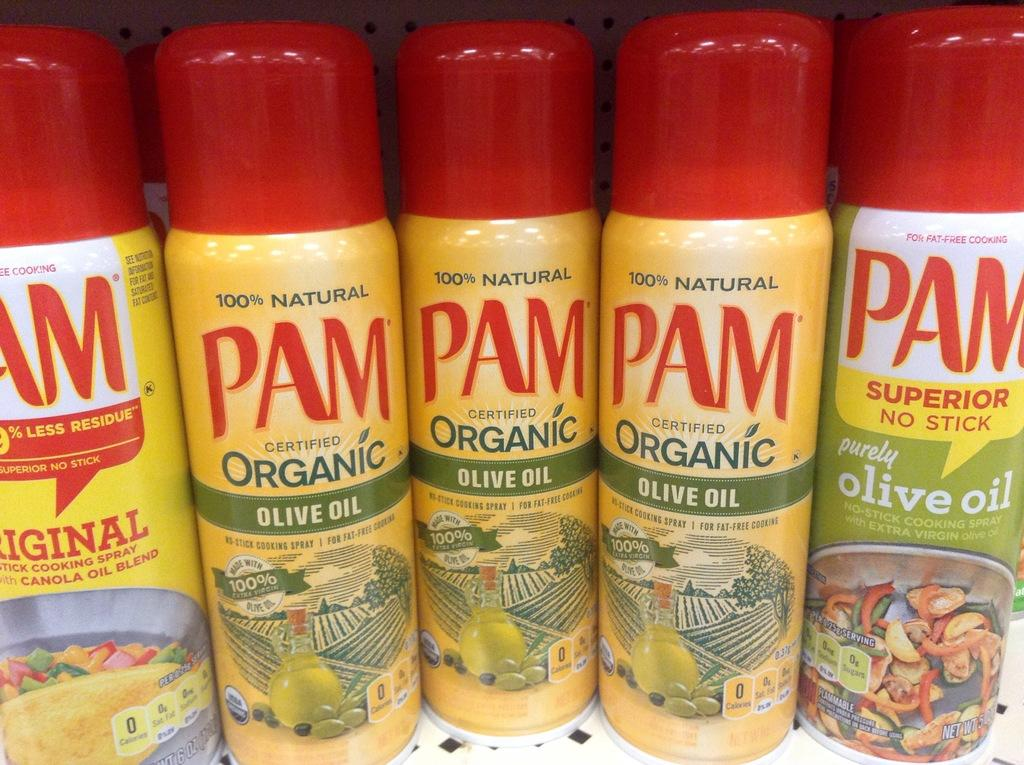What objects are present in the image? There are bottles in the image. Where are the bottles located? The bottles are placed on a surface. What can be seen behind the bottles? There is a background visible in the image. What type of fight is taking place in the image? There is no fight present in the image; it only features bottles placed on a surface. 